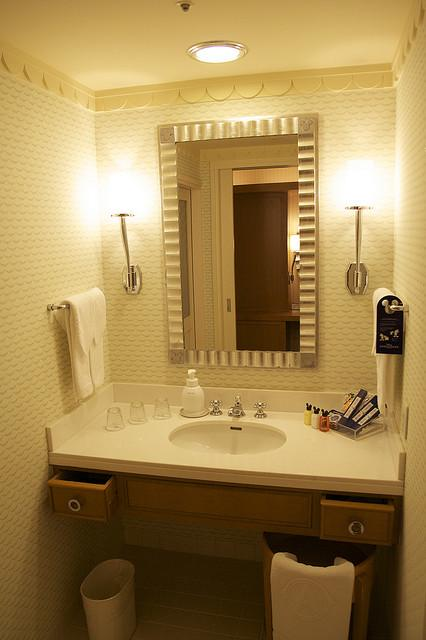Who provides the bottles on the counter?

Choices:
A) house guest
B) homeowner
C) hotel
D) customer hotel 